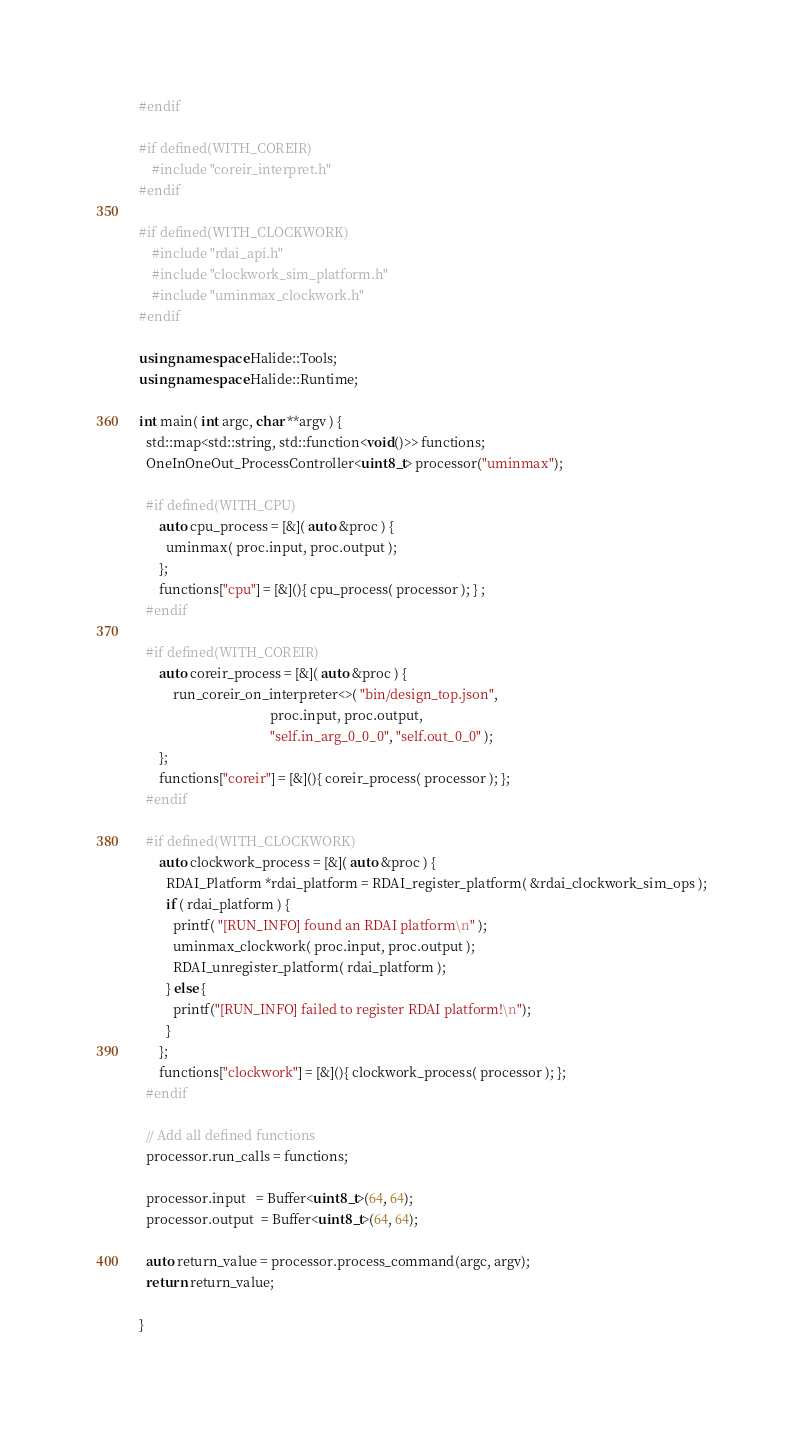Convert code to text. <code><loc_0><loc_0><loc_500><loc_500><_C++_>#endif

#if defined(WITH_COREIR)
    #include "coreir_interpret.h"
#endif

#if defined(WITH_CLOCKWORK)
    #include "rdai_api.h"
    #include "clockwork_sim_platform.h"
    #include "uminmax_clockwork.h"
#endif

using namespace Halide::Tools;
using namespace Halide::Runtime;

int main( int argc, char **argv ) {
  std::map<std::string, std::function<void()>> functions;
  OneInOneOut_ProcessController<uint8_t> processor("uminmax");

  #if defined(WITH_CPU)
      auto cpu_process = [&]( auto &proc ) {
        uminmax( proc.input, proc.output );
      };
      functions["cpu"] = [&](){ cpu_process( processor ); } ;
  #endif
  
  #if defined(WITH_COREIR)
      auto coreir_process = [&]( auto &proc ) {
          run_coreir_on_interpreter<>( "bin/design_top.json",
                                       proc.input, proc.output,
                                       "self.in_arg_0_0_0", "self.out_0_0" );
      };
      functions["coreir"] = [&](){ coreir_process( processor ); };
  #endif
  
  #if defined(WITH_CLOCKWORK)
      auto clockwork_process = [&]( auto &proc ) {
        RDAI_Platform *rdai_platform = RDAI_register_platform( &rdai_clockwork_sim_ops );
        if ( rdai_platform ) {
          printf( "[RUN_INFO] found an RDAI platform\n" );
          uminmax_clockwork( proc.input, proc.output );
          RDAI_unregister_platform( rdai_platform );
        } else {
          printf("[RUN_INFO] failed to register RDAI platform!\n");
        }
      };
      functions["clockwork"] = [&](){ clockwork_process( processor ); };
  #endif

  // Add all defined functions
  processor.run_calls = functions;

  processor.input   = Buffer<uint8_t>(64, 64);
  processor.output  = Buffer<uint8_t>(64, 64);

  auto return_value = processor.process_command(argc, argv);
  return return_value;
  
}
</code> 